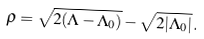Convert formula to latex. <formula><loc_0><loc_0><loc_500><loc_500>\rho = \sqrt { 2 ( \Lambda - \Lambda _ { 0 } ) } - \sqrt { 2 | \Lambda _ { 0 } | } \, .</formula> 